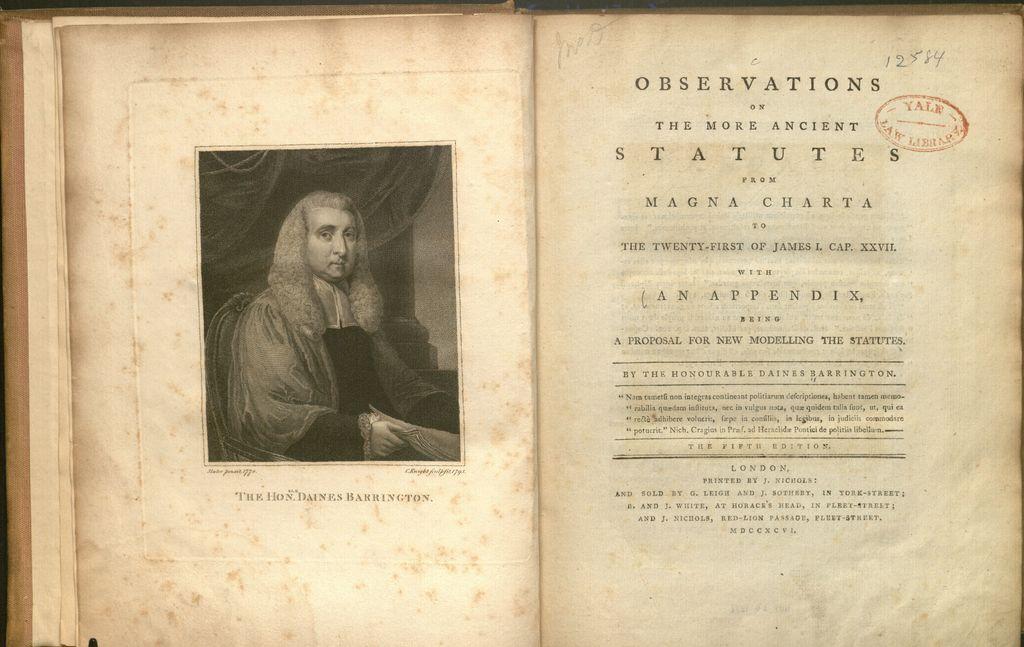What book is that?
Your response must be concise. Observations. What number is written in pen at the top right corner?
Provide a succinct answer. 12584. 